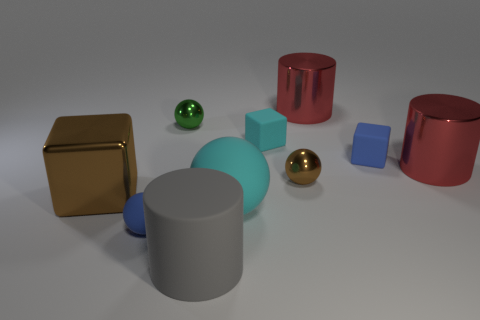What size is the matte block that is right of the red cylinder that is behind the green ball? The matte block to the right of the red cylinder, which is positioned behind the green ball, appears to be small relative to the other objects in the image. 